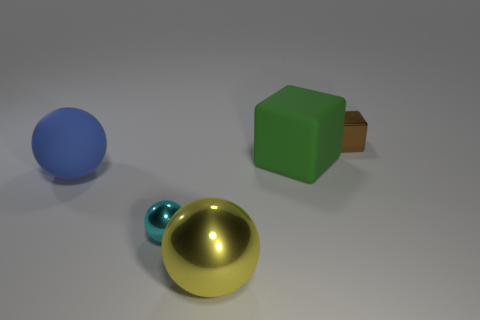Are the tiny sphere and the green thing that is behind the big yellow metallic ball made of the same material?
Your response must be concise. No. Is there any other thing that has the same size as the green matte block?
Offer a terse response. Yes. The metal cube has what color?
Keep it short and to the point. Brown. What shape is the large rubber object that is on the right side of the tiny object to the left of the small object that is behind the rubber sphere?
Your answer should be very brief. Cube. How many other objects are the same color as the big matte ball?
Offer a very short reply. 0. Is the number of big yellow objects behind the small metallic sphere greater than the number of big metal spheres to the right of the tiny brown metallic thing?
Your answer should be very brief. No. There is a green block; are there any things to the right of it?
Your answer should be very brief. Yes. The thing that is in front of the brown thing and right of the large yellow ball is made of what material?
Your answer should be very brief. Rubber. What color is the small metallic object that is the same shape as the large blue rubber thing?
Provide a succinct answer. Cyan. There is a small metallic object to the left of the tiny brown shiny object; are there any shiny things right of it?
Make the answer very short. Yes. 